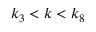Convert formula to latex. <formula><loc_0><loc_0><loc_500><loc_500>k _ { 3 } < k < k _ { 8 }</formula> 